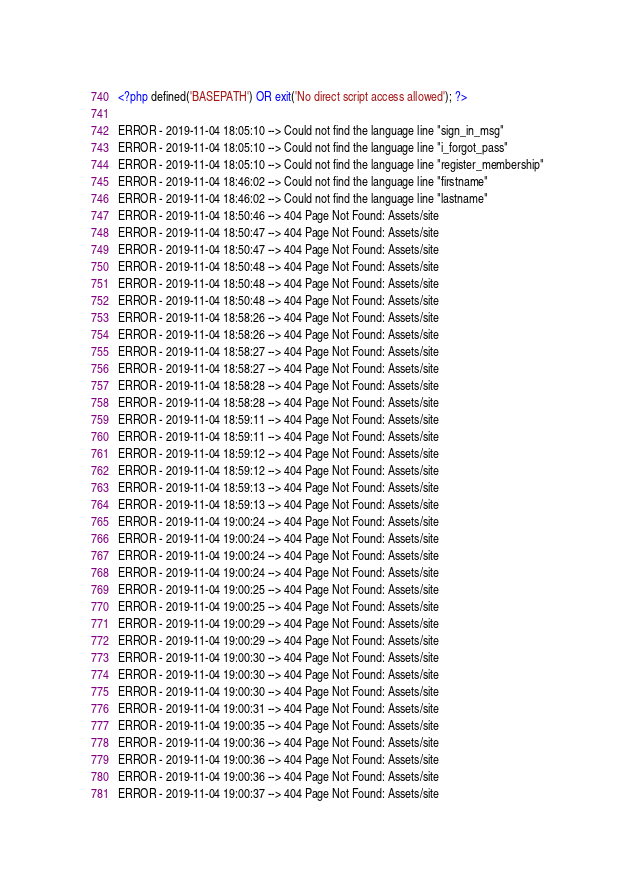<code> <loc_0><loc_0><loc_500><loc_500><_PHP_><?php defined('BASEPATH') OR exit('No direct script access allowed'); ?>

ERROR - 2019-11-04 18:05:10 --> Could not find the language line "sign_in_msg"
ERROR - 2019-11-04 18:05:10 --> Could not find the language line "i_forgot_pass"
ERROR - 2019-11-04 18:05:10 --> Could not find the language line "register_membership"
ERROR - 2019-11-04 18:46:02 --> Could not find the language line "firstname"
ERROR - 2019-11-04 18:46:02 --> Could not find the language line "lastname"
ERROR - 2019-11-04 18:50:46 --> 404 Page Not Found: Assets/site
ERROR - 2019-11-04 18:50:47 --> 404 Page Not Found: Assets/site
ERROR - 2019-11-04 18:50:47 --> 404 Page Not Found: Assets/site
ERROR - 2019-11-04 18:50:48 --> 404 Page Not Found: Assets/site
ERROR - 2019-11-04 18:50:48 --> 404 Page Not Found: Assets/site
ERROR - 2019-11-04 18:50:48 --> 404 Page Not Found: Assets/site
ERROR - 2019-11-04 18:58:26 --> 404 Page Not Found: Assets/site
ERROR - 2019-11-04 18:58:26 --> 404 Page Not Found: Assets/site
ERROR - 2019-11-04 18:58:27 --> 404 Page Not Found: Assets/site
ERROR - 2019-11-04 18:58:27 --> 404 Page Not Found: Assets/site
ERROR - 2019-11-04 18:58:28 --> 404 Page Not Found: Assets/site
ERROR - 2019-11-04 18:58:28 --> 404 Page Not Found: Assets/site
ERROR - 2019-11-04 18:59:11 --> 404 Page Not Found: Assets/site
ERROR - 2019-11-04 18:59:11 --> 404 Page Not Found: Assets/site
ERROR - 2019-11-04 18:59:12 --> 404 Page Not Found: Assets/site
ERROR - 2019-11-04 18:59:12 --> 404 Page Not Found: Assets/site
ERROR - 2019-11-04 18:59:13 --> 404 Page Not Found: Assets/site
ERROR - 2019-11-04 18:59:13 --> 404 Page Not Found: Assets/site
ERROR - 2019-11-04 19:00:24 --> 404 Page Not Found: Assets/site
ERROR - 2019-11-04 19:00:24 --> 404 Page Not Found: Assets/site
ERROR - 2019-11-04 19:00:24 --> 404 Page Not Found: Assets/site
ERROR - 2019-11-04 19:00:24 --> 404 Page Not Found: Assets/site
ERROR - 2019-11-04 19:00:25 --> 404 Page Not Found: Assets/site
ERROR - 2019-11-04 19:00:25 --> 404 Page Not Found: Assets/site
ERROR - 2019-11-04 19:00:29 --> 404 Page Not Found: Assets/site
ERROR - 2019-11-04 19:00:29 --> 404 Page Not Found: Assets/site
ERROR - 2019-11-04 19:00:30 --> 404 Page Not Found: Assets/site
ERROR - 2019-11-04 19:00:30 --> 404 Page Not Found: Assets/site
ERROR - 2019-11-04 19:00:30 --> 404 Page Not Found: Assets/site
ERROR - 2019-11-04 19:00:31 --> 404 Page Not Found: Assets/site
ERROR - 2019-11-04 19:00:35 --> 404 Page Not Found: Assets/site
ERROR - 2019-11-04 19:00:36 --> 404 Page Not Found: Assets/site
ERROR - 2019-11-04 19:00:36 --> 404 Page Not Found: Assets/site
ERROR - 2019-11-04 19:00:36 --> 404 Page Not Found: Assets/site
ERROR - 2019-11-04 19:00:37 --> 404 Page Not Found: Assets/site</code> 